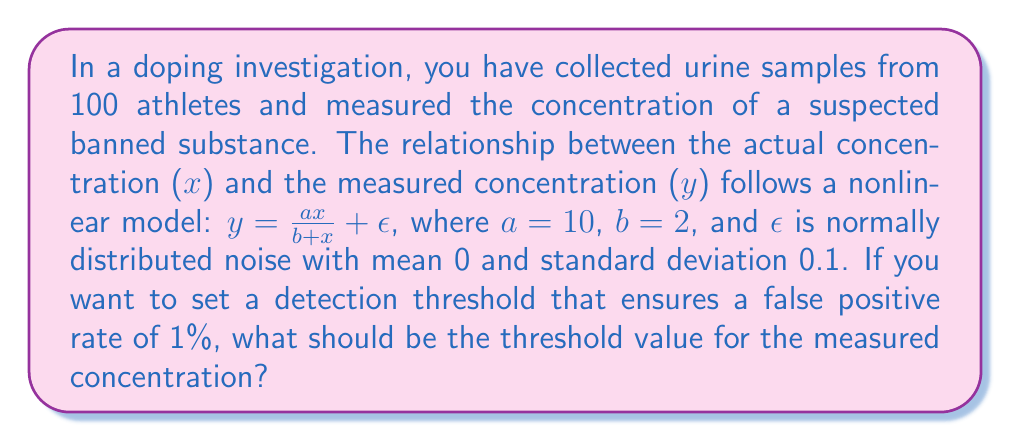What is the answer to this math problem? To determine the detection threshold, we need to follow these steps:

1) First, we need to understand that when there's no banned substance present ($x=0$), the measured concentration will only be due to noise ($\epsilon$).

2) The noise $\epsilon$ is normally distributed with mean 0 and standard deviation 0.1. Therefore, the measured concentration when $x=0$ follows a normal distribution $N(0, 0.1^2)$.

3) To ensure a false positive rate of 1%, we need to find the 99th percentile of this distribution. This can be calculated using the inverse of the standard normal cumulative distribution function (also known as the probit function) multiplied by the standard deviation, plus the mean.

4) The 99th percentile of a standard normal distribution is approximately 2.326. Therefore, our threshold $T$ is:

   $T = 0 + 2.326 * 0.1 = 0.2326$

5) Any measured concentration above 0.2326 will be considered as a positive test result, with a 1% chance of being a false positive.

To verify:
$P(Y > 0.2326 | X = 0) = 1 - \Phi(\frac{0.2326 - 0}{0.1}) = 1 - \Phi(2.326) \approx 0.01$

Where $\Phi$ is the cumulative distribution function of the standard normal distribution.
Answer: 0.2326 